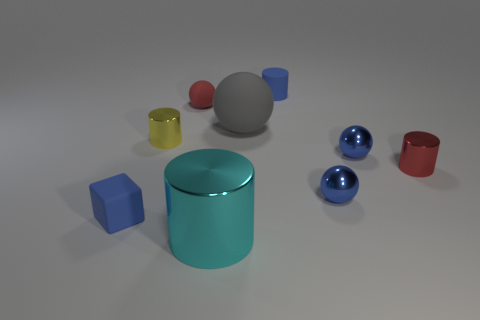Subtract all cubes. How many objects are left? 8 Subtract 2 blue spheres. How many objects are left? 7 Subtract all small matte cylinders. Subtract all large purple objects. How many objects are left? 8 Add 8 small blue matte cylinders. How many small blue matte cylinders are left? 9 Add 2 large metallic cylinders. How many large metallic cylinders exist? 3 